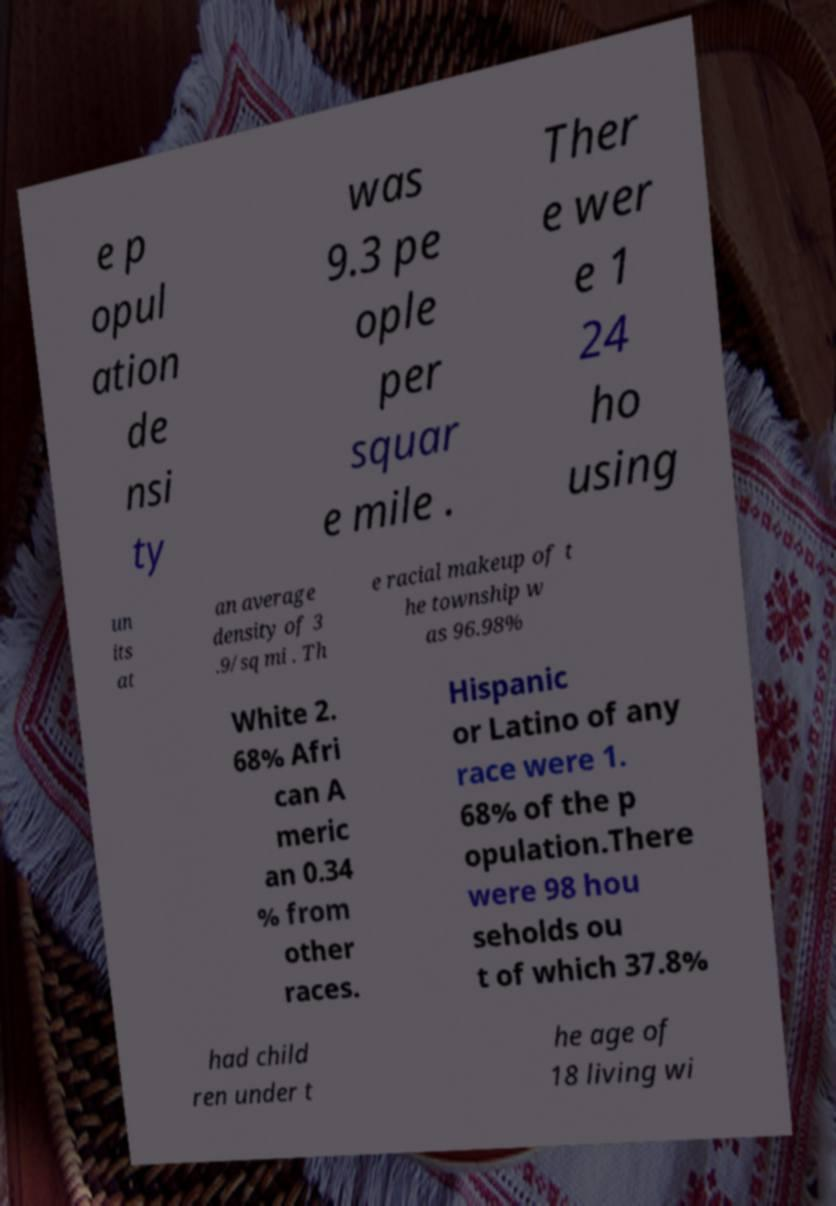Could you assist in decoding the text presented in this image and type it out clearly? e p opul ation de nsi ty was 9.3 pe ople per squar e mile . Ther e wer e 1 24 ho using un its at an average density of 3 .9/sq mi . Th e racial makeup of t he township w as 96.98% White 2. 68% Afri can A meric an 0.34 % from other races. Hispanic or Latino of any race were 1. 68% of the p opulation.There were 98 hou seholds ou t of which 37.8% had child ren under t he age of 18 living wi 